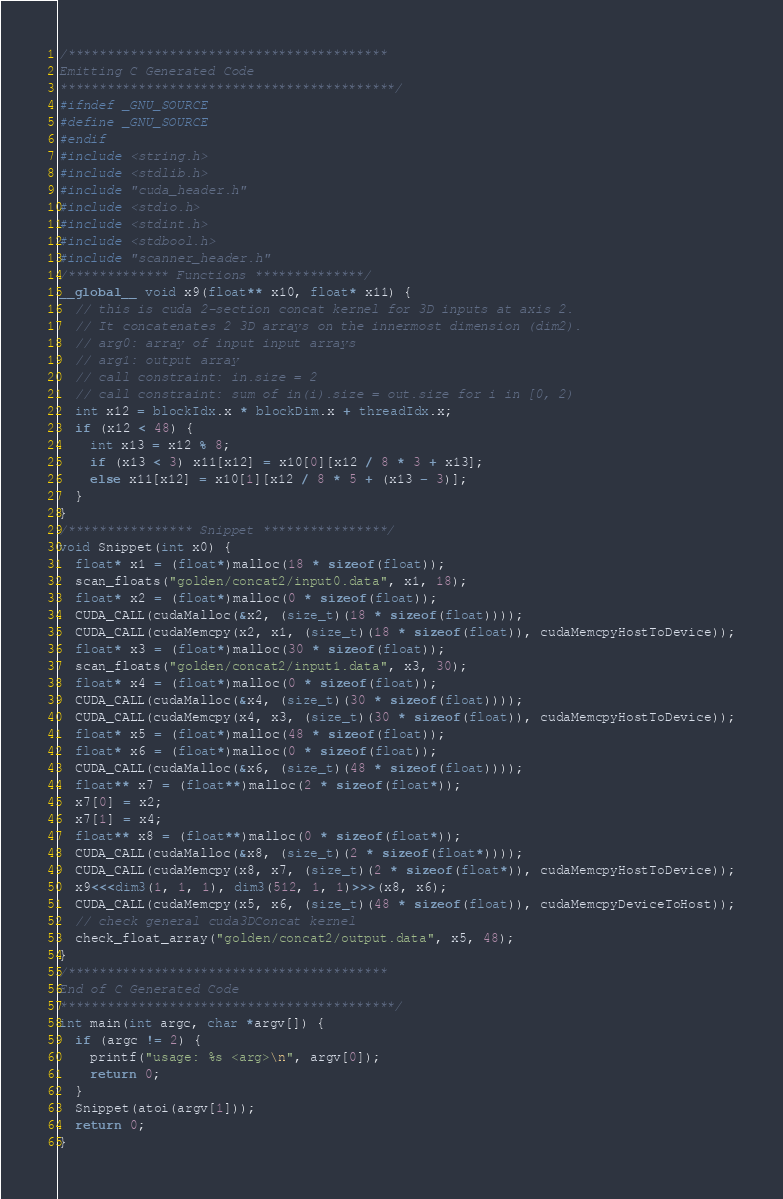Convert code to text. <code><loc_0><loc_0><loc_500><loc_500><_Cuda_>/*****************************************
Emitting C Generated Code
*******************************************/
#ifndef _GNU_SOURCE
#define _GNU_SOURCE
#endif
#include <string.h>
#include <stdlib.h>
#include "cuda_header.h"
#include <stdio.h>
#include <stdint.h>
#include <stdbool.h>
#include "scanner_header.h"
/************* Functions **************/
__global__ void x9(float** x10, float* x11) {
  // this is cuda 2-section concat kernel for 3D inputs at axis 2.
  // It concatenates 2 3D arrays on the innermost dimension (dim2).
  // arg0: array of input input arrays
  // arg1: output array
  // call constraint: in.size = 2
  // call constraint: sum of in(i).size = out.size for i in [0, 2)
  int x12 = blockIdx.x * blockDim.x + threadIdx.x;
  if (x12 < 48) {
    int x13 = x12 % 8;
    if (x13 < 3) x11[x12] = x10[0][x12 / 8 * 3 + x13];
    else x11[x12] = x10[1][x12 / 8 * 5 + (x13 - 3)];
  }
}
/**************** Snippet ****************/
void Snippet(int x0) {
  float* x1 = (float*)malloc(18 * sizeof(float));
  scan_floats("golden/concat2/input0.data", x1, 18);
  float* x2 = (float*)malloc(0 * sizeof(float));
  CUDA_CALL(cudaMalloc(&x2, (size_t)(18 * sizeof(float))));
  CUDA_CALL(cudaMemcpy(x2, x1, (size_t)(18 * sizeof(float)), cudaMemcpyHostToDevice));
  float* x3 = (float*)malloc(30 * sizeof(float));
  scan_floats("golden/concat2/input1.data", x3, 30);
  float* x4 = (float*)malloc(0 * sizeof(float));
  CUDA_CALL(cudaMalloc(&x4, (size_t)(30 * sizeof(float))));
  CUDA_CALL(cudaMemcpy(x4, x3, (size_t)(30 * sizeof(float)), cudaMemcpyHostToDevice));
  float* x5 = (float*)malloc(48 * sizeof(float));
  float* x6 = (float*)malloc(0 * sizeof(float));
  CUDA_CALL(cudaMalloc(&x6, (size_t)(48 * sizeof(float))));
  float** x7 = (float**)malloc(2 * sizeof(float*));
  x7[0] = x2;
  x7[1] = x4;
  float** x8 = (float**)malloc(0 * sizeof(float*));
  CUDA_CALL(cudaMalloc(&x8, (size_t)(2 * sizeof(float*))));
  CUDA_CALL(cudaMemcpy(x8, x7, (size_t)(2 * sizeof(float*)), cudaMemcpyHostToDevice));
  x9<<<dim3(1, 1, 1), dim3(512, 1, 1)>>>(x8, x6);
  CUDA_CALL(cudaMemcpy(x5, x6, (size_t)(48 * sizeof(float)), cudaMemcpyDeviceToHost));
  // check general cuda3DConcat kernel
  check_float_array("golden/concat2/output.data", x5, 48);
}
/*****************************************
End of C Generated Code
*******************************************/
int main(int argc, char *argv[]) {
  if (argc != 2) {
    printf("usage: %s <arg>\n", argv[0]);
    return 0;
  }
  Snippet(atoi(argv[1]));
  return 0;
}
</code> 